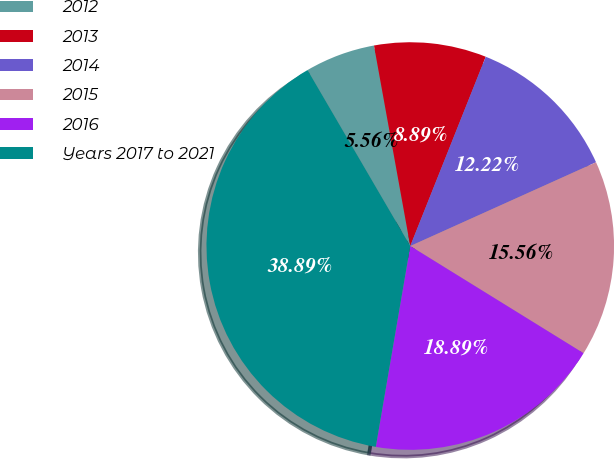Convert chart to OTSL. <chart><loc_0><loc_0><loc_500><loc_500><pie_chart><fcel>2012<fcel>2013<fcel>2014<fcel>2015<fcel>2016<fcel>Years 2017 to 2021<nl><fcel>5.56%<fcel>8.89%<fcel>12.22%<fcel>15.56%<fcel>18.89%<fcel>38.89%<nl></chart> 